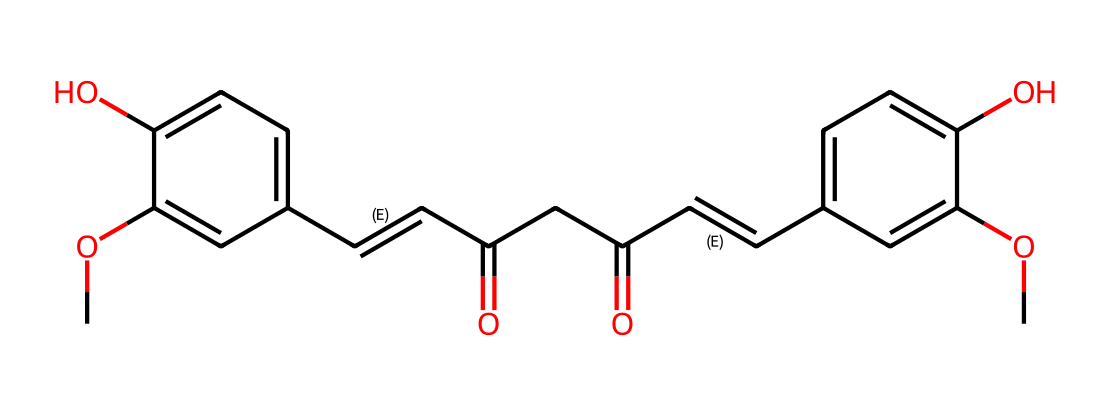What is the molecular formula of curcumin based on its structure? By analyzing the SMILES representation, we can determine the number of carbon (C), hydrogen (H), and oxygen (O) atoms in the structure. The molecular formula can be derived directly from the total count of these atoms, giving us C21H20O6.
Answer: C21H20O6 How many hydroxyl groups (-OH) are present in curcumin? In the structure, we identify the -OH groups by looking for oxygen atoms bonded to hydrogen. There are two -OH groups present in the chemical structure of curcumin.
Answer: 2 Which part of the curcumin structure contributes to its antioxidant properties? The presence of conjugated double bonds and hydroxyl groups in the structure allows curcumin to donate electrons, which is characteristic of antioxidants. This contributes to its ability to neutralize free radicals.
Answer: conjugated double bonds and hydroxyl groups How many rings are present in the curcumin structure? The SMILES representation shows that there are two aromatic rings in the structure, which are common features of many antioxidant compounds, including curcumin.
Answer: 2 What functional groups are represented in curcumin's structure? Upon examining the structure, we can identify functional groups such as hydroxyl (-OH) and carbonyl (C=O) groups, which are vital for its biological activity and solubility in water.
Answer: hydroxyl and carbonyl groups 